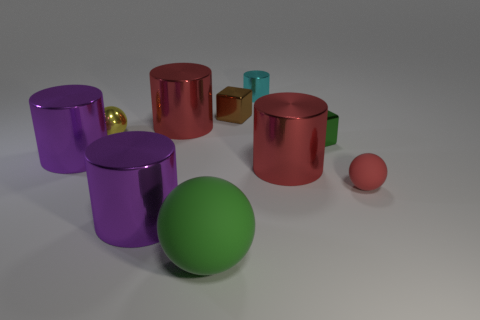There is a cyan thing that is on the right side of the green matte sphere; what material is it? The cyan object to the right of the green matte sphere appears to have a reflective surface, suggesting that it is made of a metallic material, likely aluminum or steel with a colored finish. 